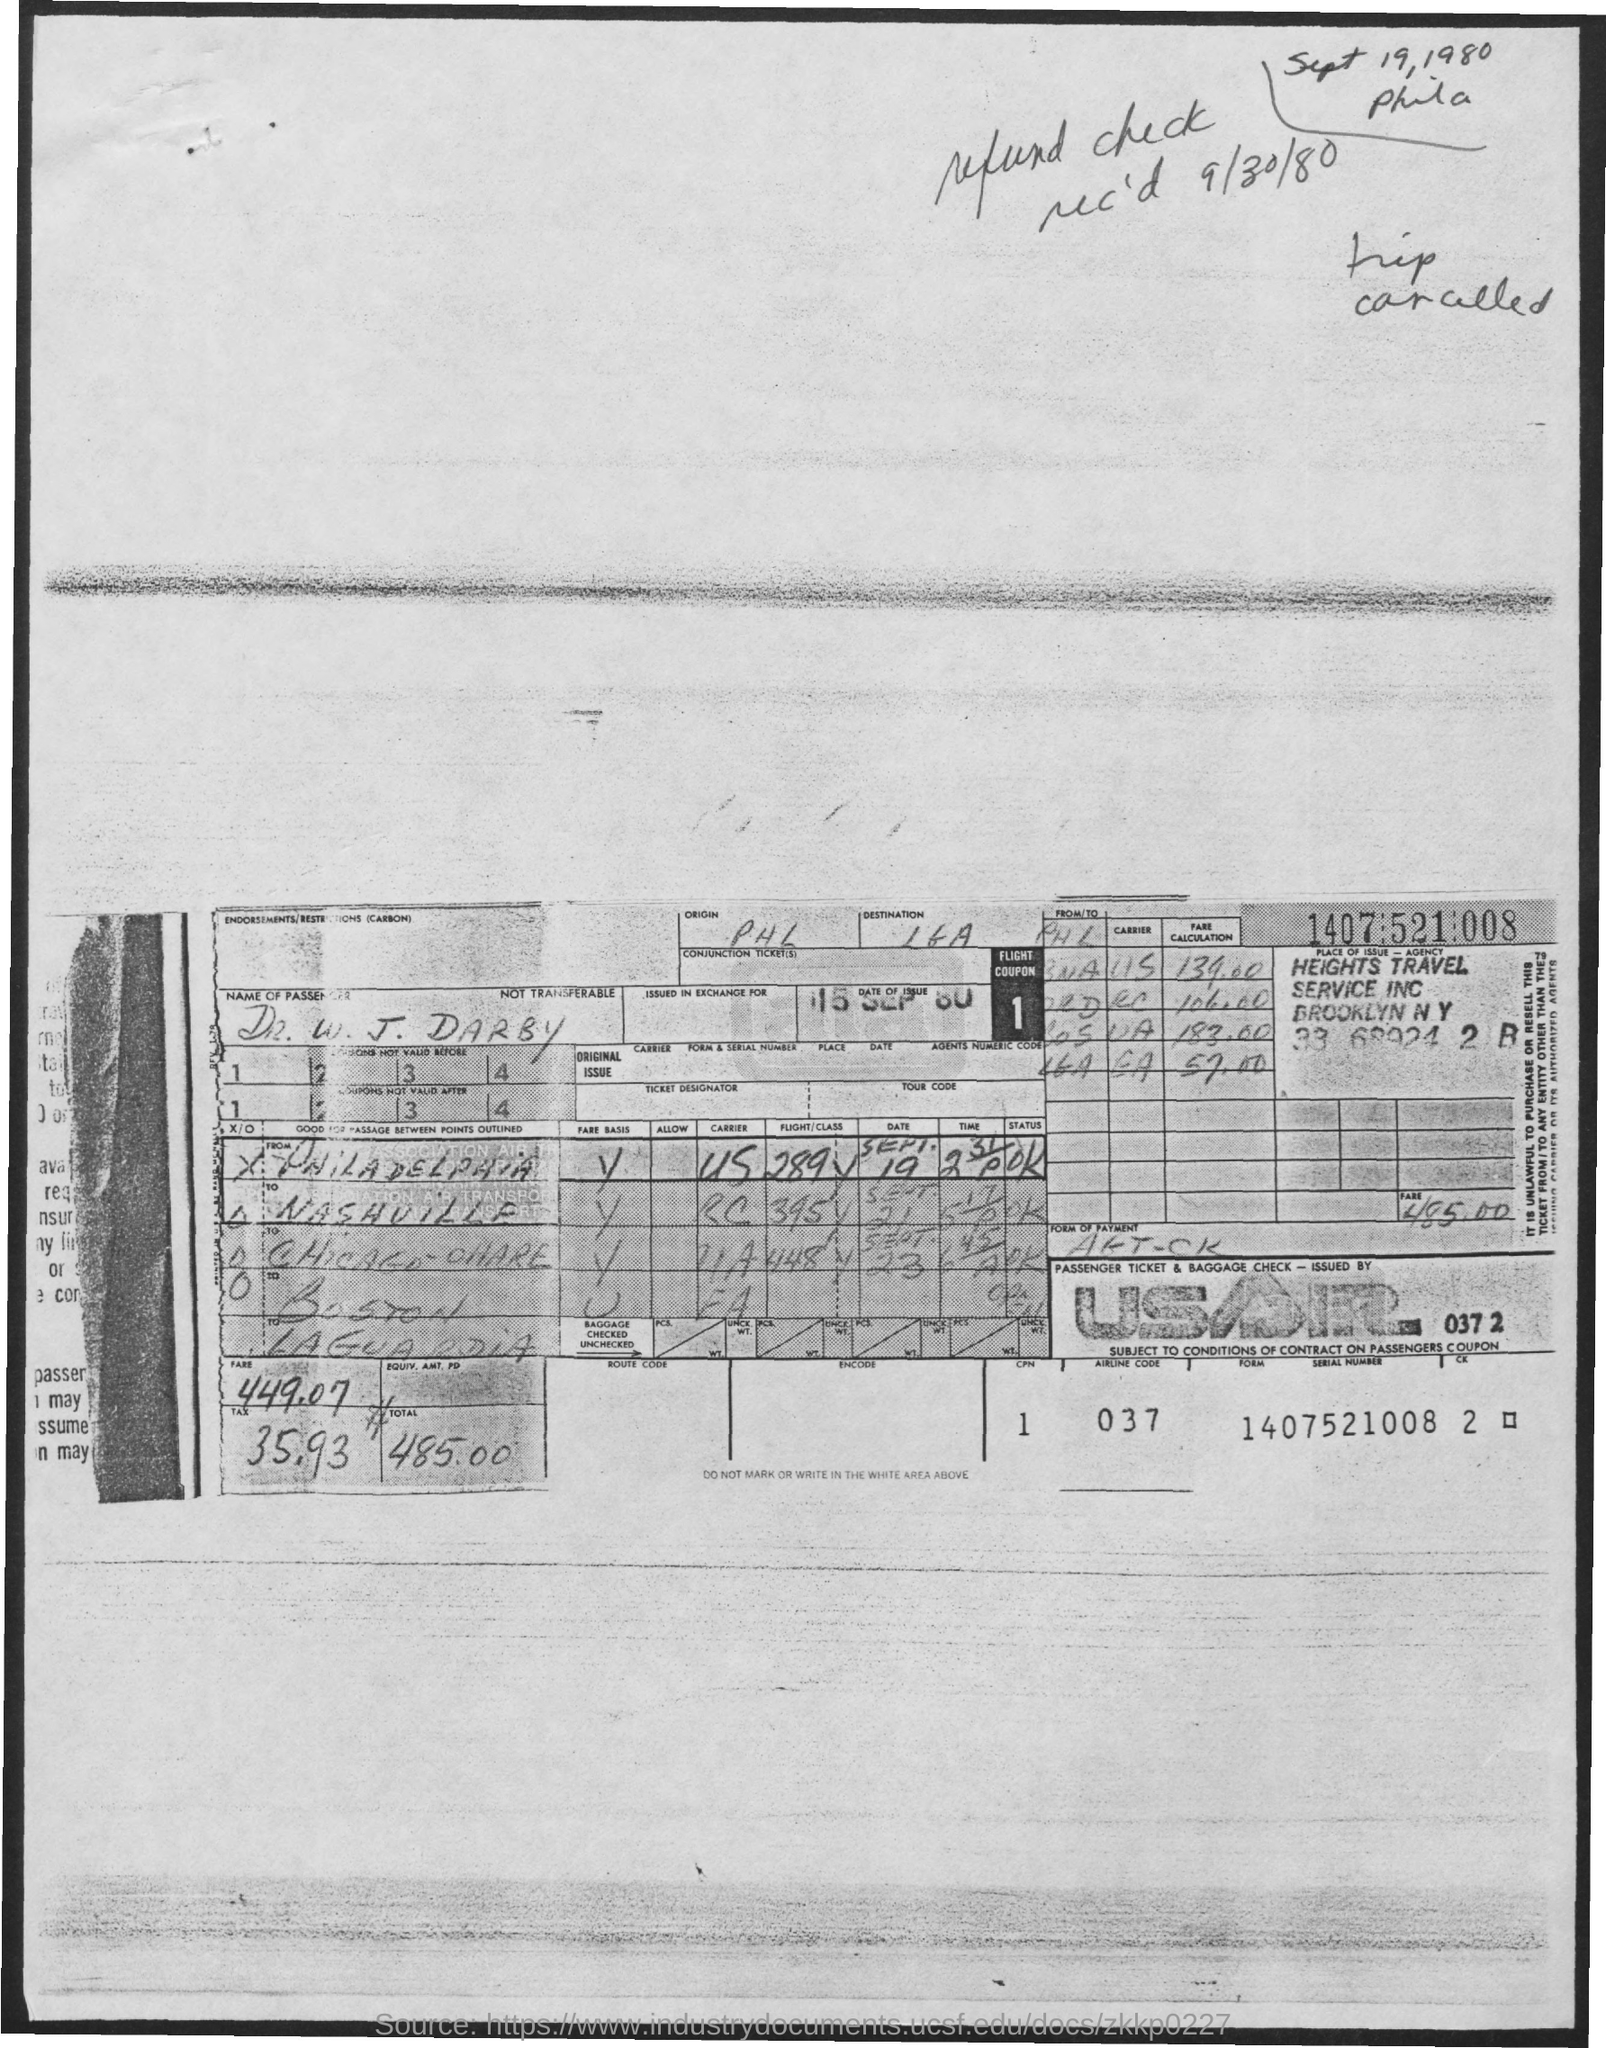What is the date of issue mentioned in the given form ?
Provide a short and direct response. 15 SEP 80. What is the name of the passenger mentioned in the given page ?
Ensure brevity in your answer.  W. J. DARBY. What is the amount of  total fare mentioned in the given page ?
Offer a terse response. 485.00. What is the airline code mentioned in the given form ?
Provide a succinct answer. 037. What is the amount for tax mentioned in the given form ?
Offer a very short reply. 35.93. 